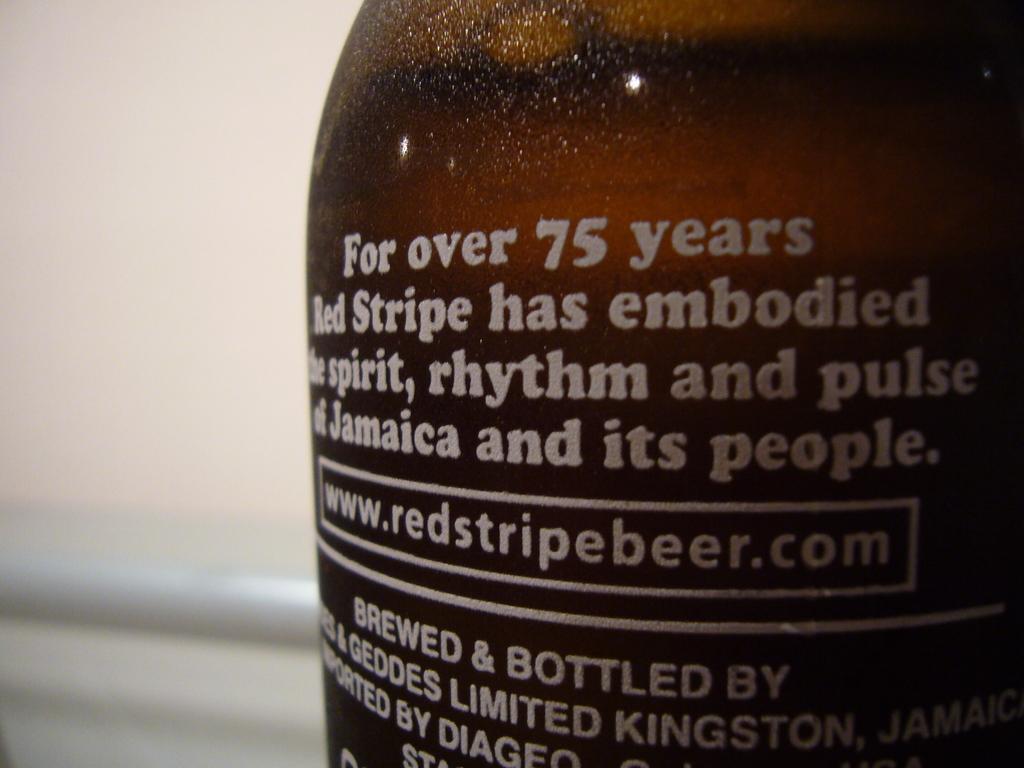How many years has red stripe been around?
Keep it short and to the point. 75. Is that a beer bottle?
Provide a short and direct response. Yes. 